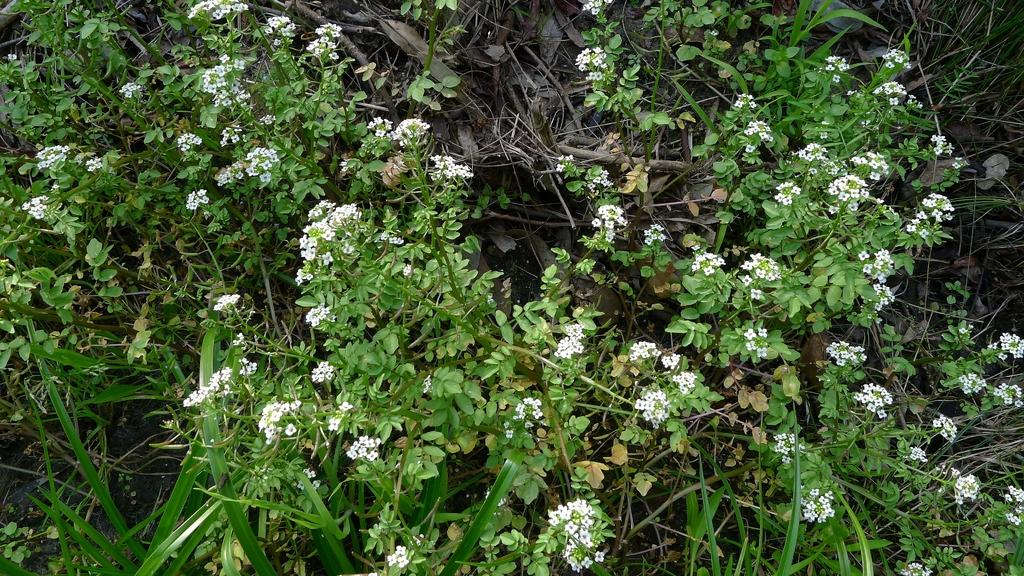What type of living organisms can be seen in the image? There are flowers and plants visible in the image. Can you describe the plants in the image? The plants in the image are not specified, but they are present alongside the flowers. How many deer can be seen grazing on the sheet in the image? There are no deer or sheets present in the image; it features flowers and plants. 